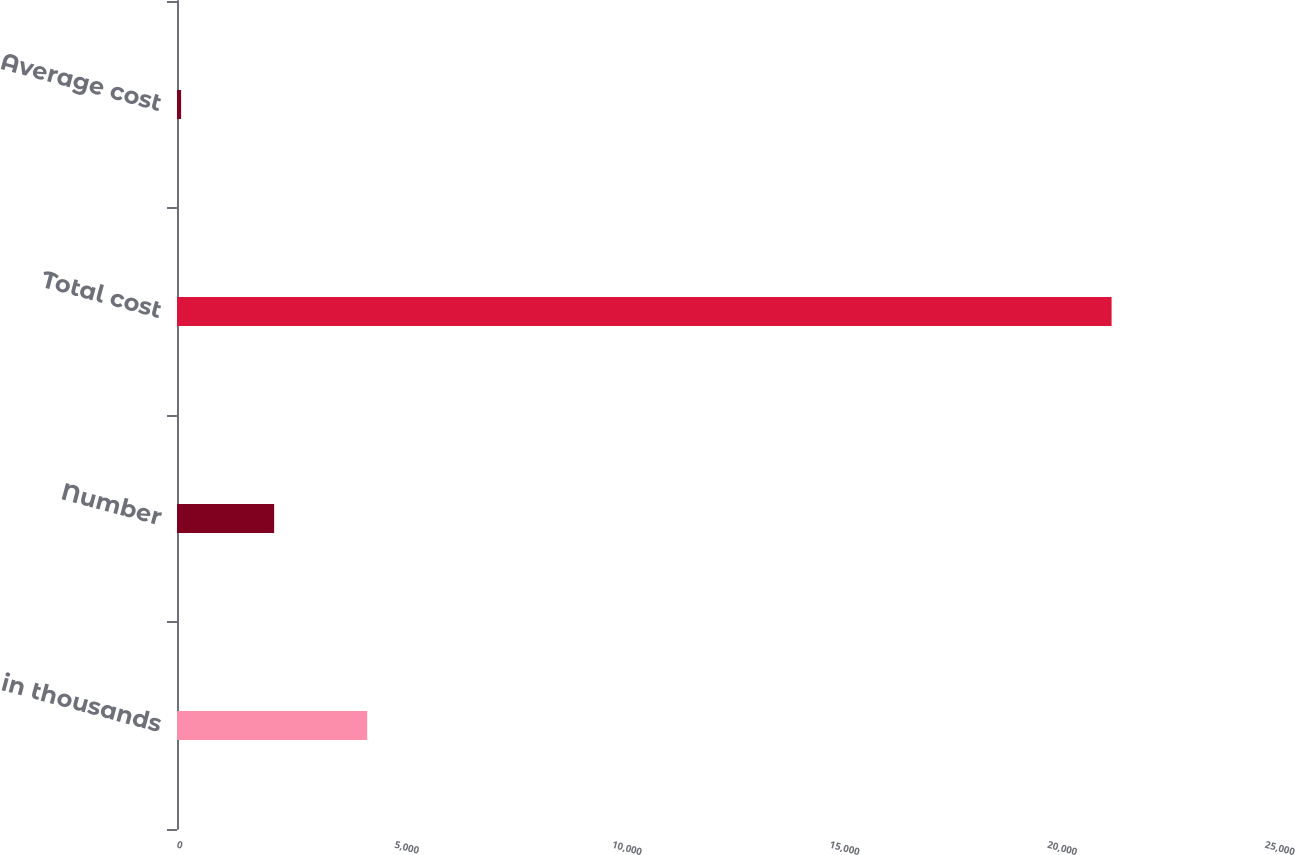Convert chart. <chart><loc_0><loc_0><loc_500><loc_500><bar_chart><fcel>in thousands<fcel>Number<fcel>Total cost<fcel>Average cost<nl><fcel>4370.35<fcel>2232.27<fcel>21475<fcel>94.19<nl></chart> 